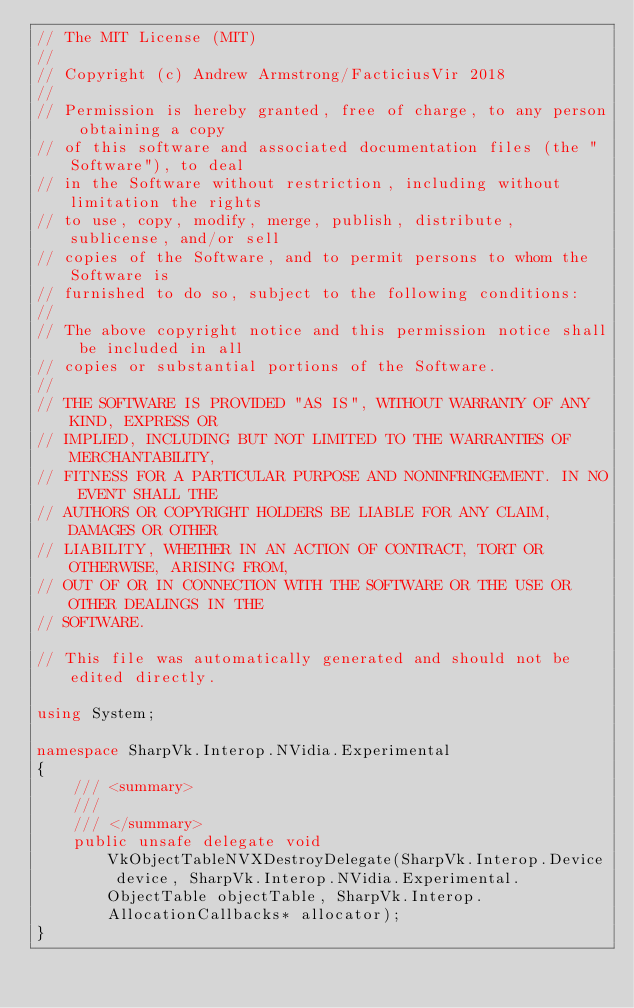Convert code to text. <code><loc_0><loc_0><loc_500><loc_500><_C#_>// The MIT License (MIT)
// 
// Copyright (c) Andrew Armstrong/FacticiusVir 2018
// 
// Permission is hereby granted, free of charge, to any person obtaining a copy
// of this software and associated documentation files (the "Software"), to deal
// in the Software without restriction, including without limitation the rights
// to use, copy, modify, merge, publish, distribute, sublicense, and/or sell
// copies of the Software, and to permit persons to whom the Software is
// furnished to do so, subject to the following conditions:
// 
// The above copyright notice and this permission notice shall be included in all
// copies or substantial portions of the Software.
// 
// THE SOFTWARE IS PROVIDED "AS IS", WITHOUT WARRANTY OF ANY KIND, EXPRESS OR
// IMPLIED, INCLUDING BUT NOT LIMITED TO THE WARRANTIES OF MERCHANTABILITY,
// FITNESS FOR A PARTICULAR PURPOSE AND NONINFRINGEMENT. IN NO EVENT SHALL THE
// AUTHORS OR COPYRIGHT HOLDERS BE LIABLE FOR ANY CLAIM, DAMAGES OR OTHER
// LIABILITY, WHETHER IN AN ACTION OF CONTRACT, TORT OR OTHERWISE, ARISING FROM,
// OUT OF OR IN CONNECTION WITH THE SOFTWARE OR THE USE OR OTHER DEALINGS IN THE
// SOFTWARE.

// This file was automatically generated and should not be edited directly.

using System;

namespace SharpVk.Interop.NVidia.Experimental
{
    /// <summary>
    /// 
    /// </summary>
    public unsafe delegate void VkObjectTableNVXDestroyDelegate(SharpVk.Interop.Device device, SharpVk.Interop.NVidia.Experimental.ObjectTable objectTable, SharpVk.Interop.AllocationCallbacks* allocator);
}
</code> 